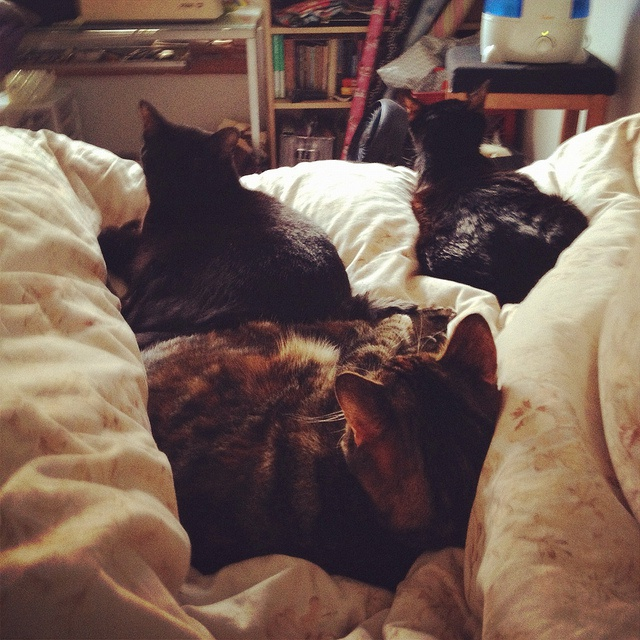Describe the objects in this image and their specific colors. I can see bed in darkgray, gray, tan, and beige tones, cat in darkgray, black, maroon, and brown tones, cat in darkgray, black, and brown tones, cat in darkgray, black, maroon, gray, and ivory tones, and book in darkgray, maroon, black, gray, and brown tones in this image. 